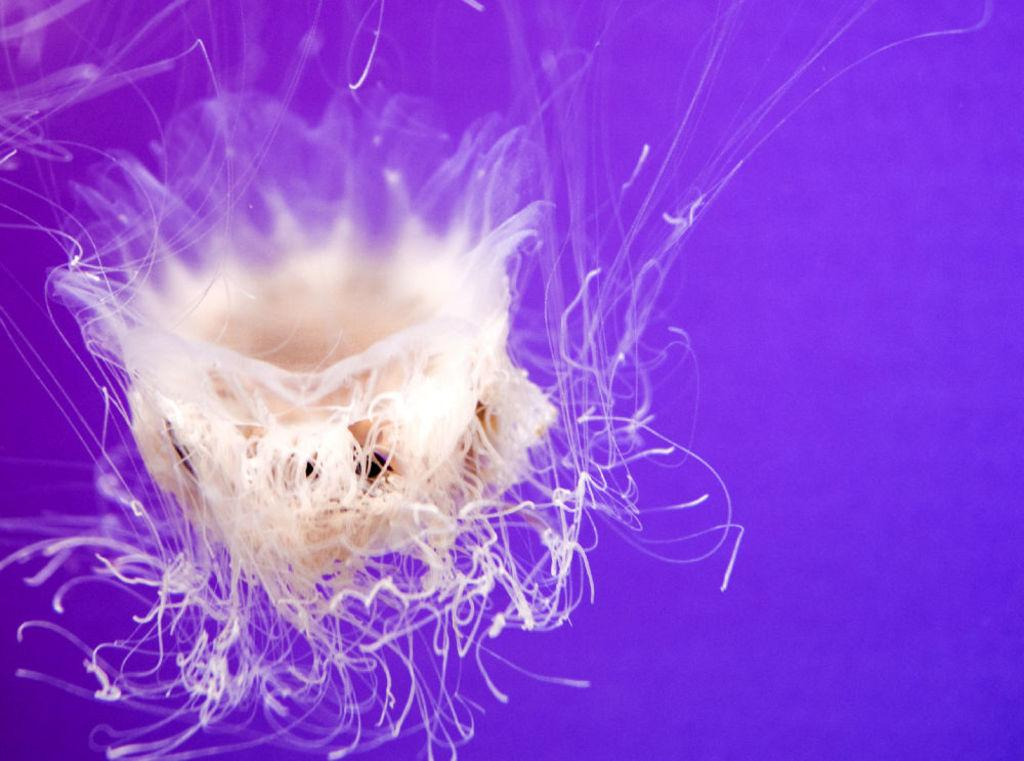What type of sea creatures are in the image? There are jellyfish in the image. What color is the background of the image? The background of the image is violet. How many potatoes can be seen in the image? There are no potatoes present in the image; it features jellyfish in a violet background. What type of whip is being used by the jellyfish in the image? There is no whip present in the image, as it features jellyfish in a violet background. 